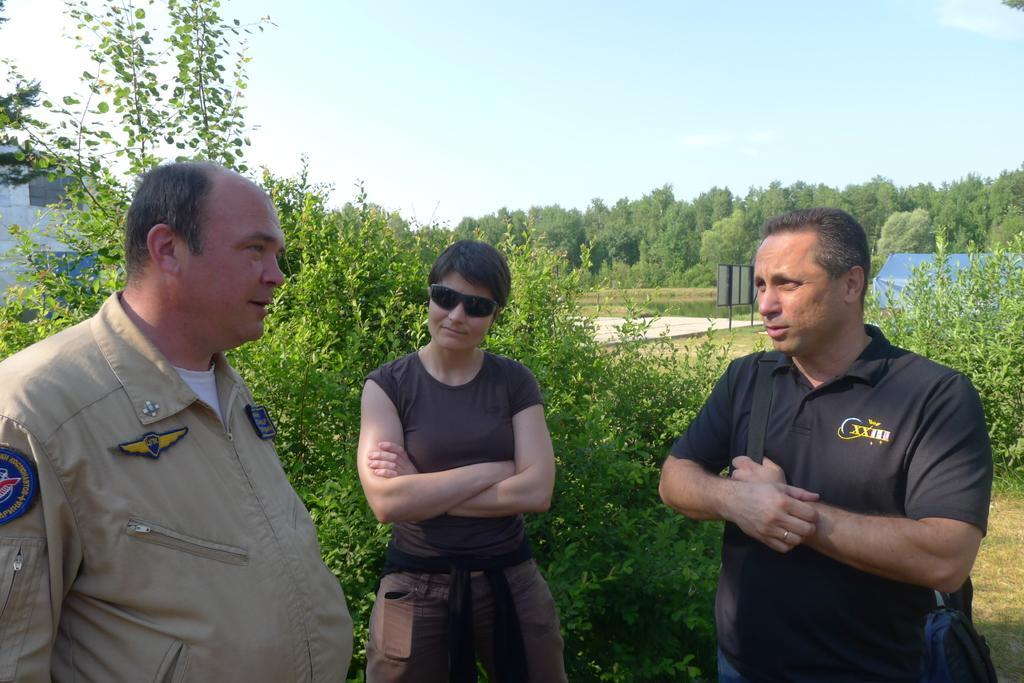In one or two sentences, can you explain what this image depicts? In this image I can see three persons are standing on the ground. In the background few trees which are green in color, a blue colored tent, a board, a building and the sky. 